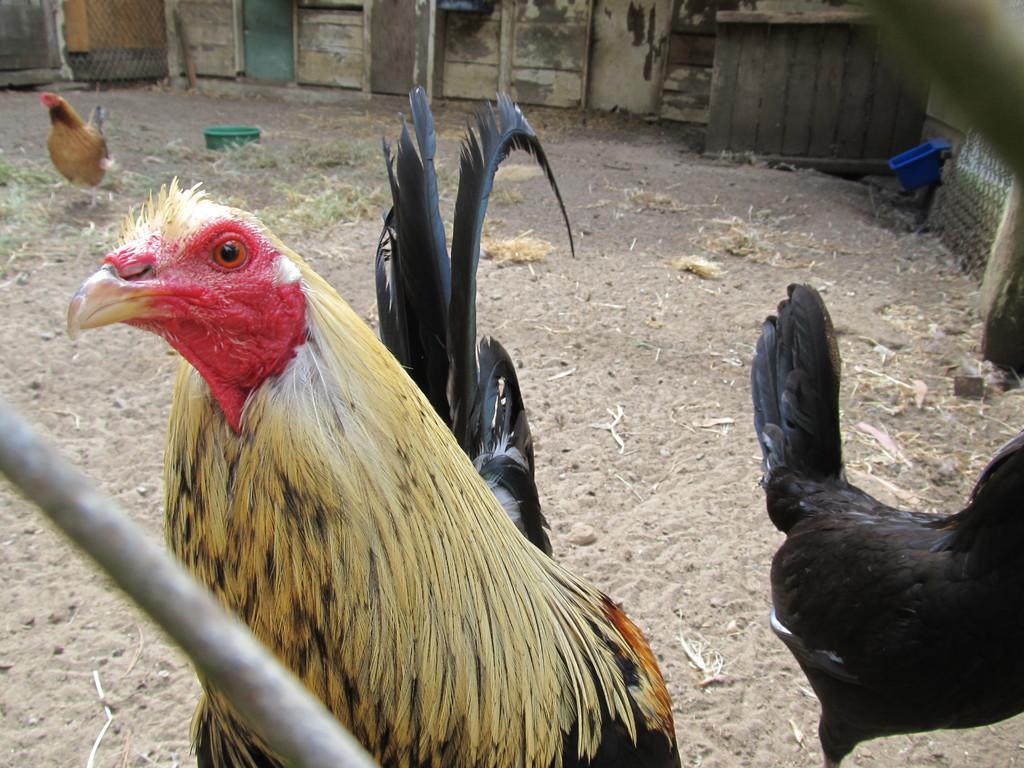Could you give a brief overview of what you see in this image? In this image we can see hens on the ground. Here we can see grass, rod, and baskets. In the background we can see wall. 